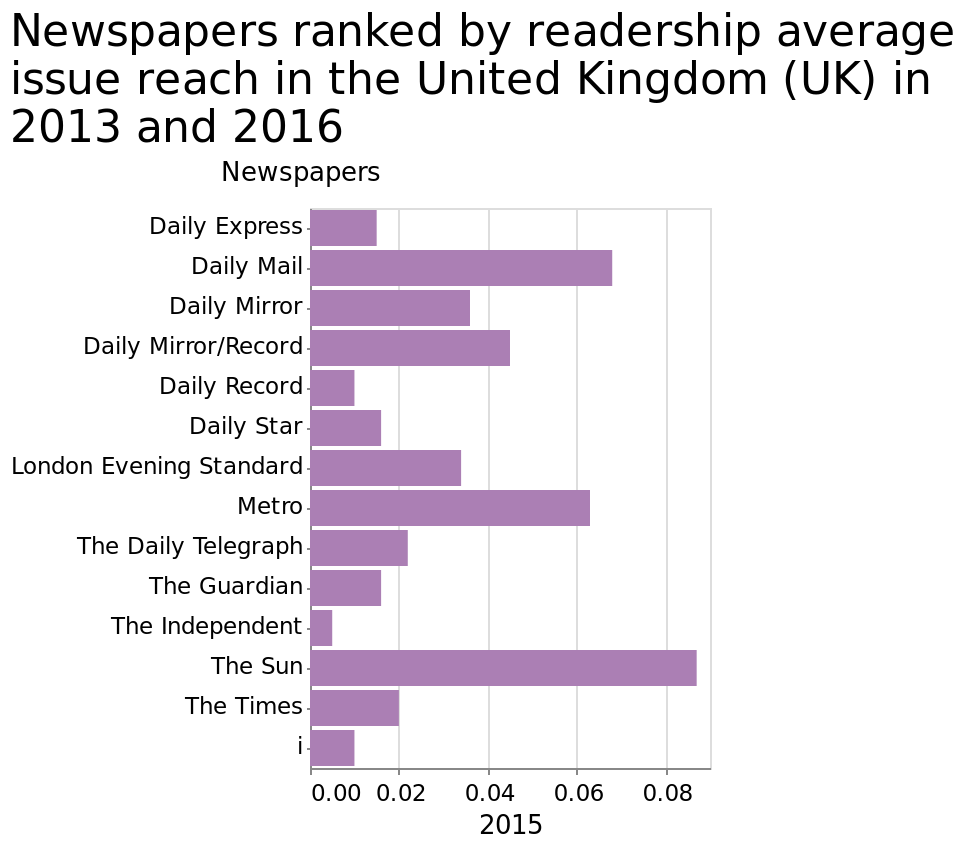<image>
What magazine is recommended for its trustworthy and popular content? The Guardian. please describe the details of the chart Here a bar graph is labeled Newspapers ranked by readership average issue reach in the United Kingdom (UK) in 2013 and 2016. The y-axis measures Newspapers on a categorical scale from Daily Express to i. There is a linear scale with a minimum of 0.00 and a maximum of 0.08 on the x-axis, marked 2015. Which magazine appears to be the strongest selling throughout the entire time period?  The Guardian. What is being measured on the y-axis of the bar graph?  The y-axis of the bar graph measures the average issue reach of newspapers in the United Kingdom (UK). Offer a thorough analysis of the image. Th e guardian appears to be the strongest selling magazine throughout the entire time period, papers that seem to sell real news rather than enflated news seem to be better sellers. What is the maximum value on the x-axis of the bar graph?  The maximum value on the x-axis of the bar graph is 0.08. Is a bar graph labeled Magazines ranked by readership average issue reach in the United Kingdom (UK) in 2013 and 2016? No.Here a bar graph is labeled Newspapers ranked by readership average issue reach in the United Kingdom (UK) in 2013 and 2016. The y-axis measures Newspapers on a categorical scale from Daily Express to i. There is a linear scale with a minimum of 0.00 and a maximum of 0.08 on the x-axis, marked 2015. 